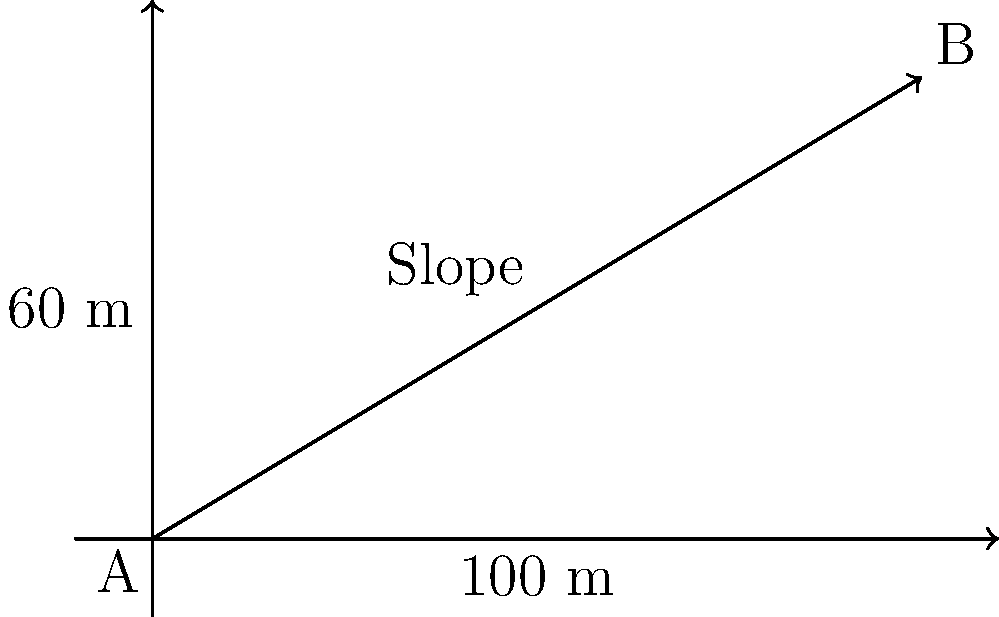As a shepherd, you need to determine if a hillside is safe for your flock to graze. The hillside rises 60 meters over a horizontal distance of 100 meters. What is the slope of this hillside expressed as a percentage? To find the slope as a percentage, we need to follow these steps:

1. Identify the rise (vertical change) and run (horizontal change):
   Rise = 60 meters
   Run = 100 meters

2. Calculate the slope using the formula:
   Slope = (Rise / Run) × 100%

3. Plug in the values:
   Slope = (60 m / 100 m) × 100%

4. Simplify:
   Slope = 0.6 × 100%

5. Calculate the final percentage:
   Slope = 60%

Therefore, the slope of the hillside is 60%.
Answer: 60% 